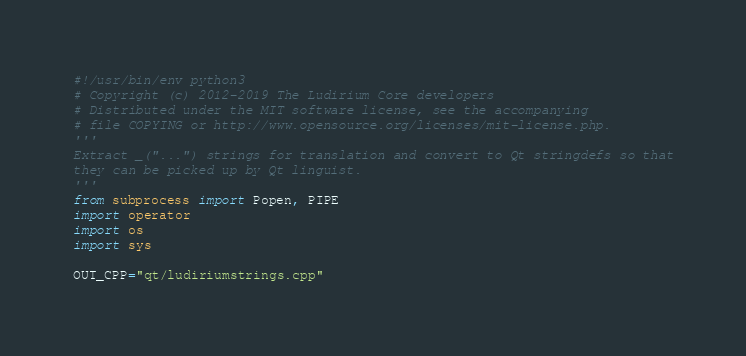<code> <loc_0><loc_0><loc_500><loc_500><_Python_>#!/usr/bin/env python3
# Copyright (c) 2012-2019 The Ludirium Core developers
# Distributed under the MIT software license, see the accompanying
# file COPYING or http://www.opensource.org/licenses/mit-license.php.
'''
Extract _("...") strings for translation and convert to Qt stringdefs so that
they can be picked up by Qt linguist.
'''
from subprocess import Popen, PIPE
import operator
import os
import sys

OUT_CPP="qt/ludiriumstrings.cpp"</code> 